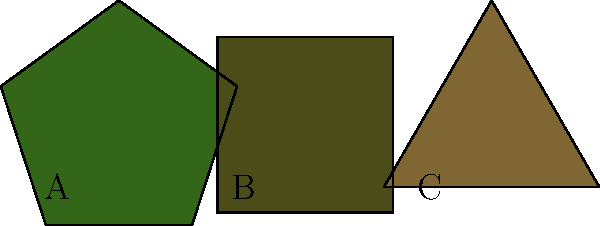In the pattern recognition test above, three camouflage designs from different eras are shown. Which design is most likely to represent the modern digital camouflage pattern used in recent military operations? To identify the modern digital camouflage pattern, we need to analyze the characteristics of each design:

1. Design A (pentagon):
   - Represents older, solid color camouflage
   - Used in earlier eras of warfare

2. Design B (square):
   - Represents a transitional camouflage pattern
   - More geometric than A, but still not fully "digital"

3. Design C (triangle):
   - Represents the most angular and geometric shape
   - Closest to the pixelated appearance of modern digital camouflage

Modern digital camouflage patterns are characterized by their use of small, angular shapes that create a pixelated effect. This design helps break up the wearer's outline and makes them harder to detect in various environments.

The triangular shape in Design C most closely resembles the angular, fragmented patterns used in modern digital camouflage. It represents the evolution of camouflage design towards more effective concealment in diverse terrains and urban environments.
Answer: C 